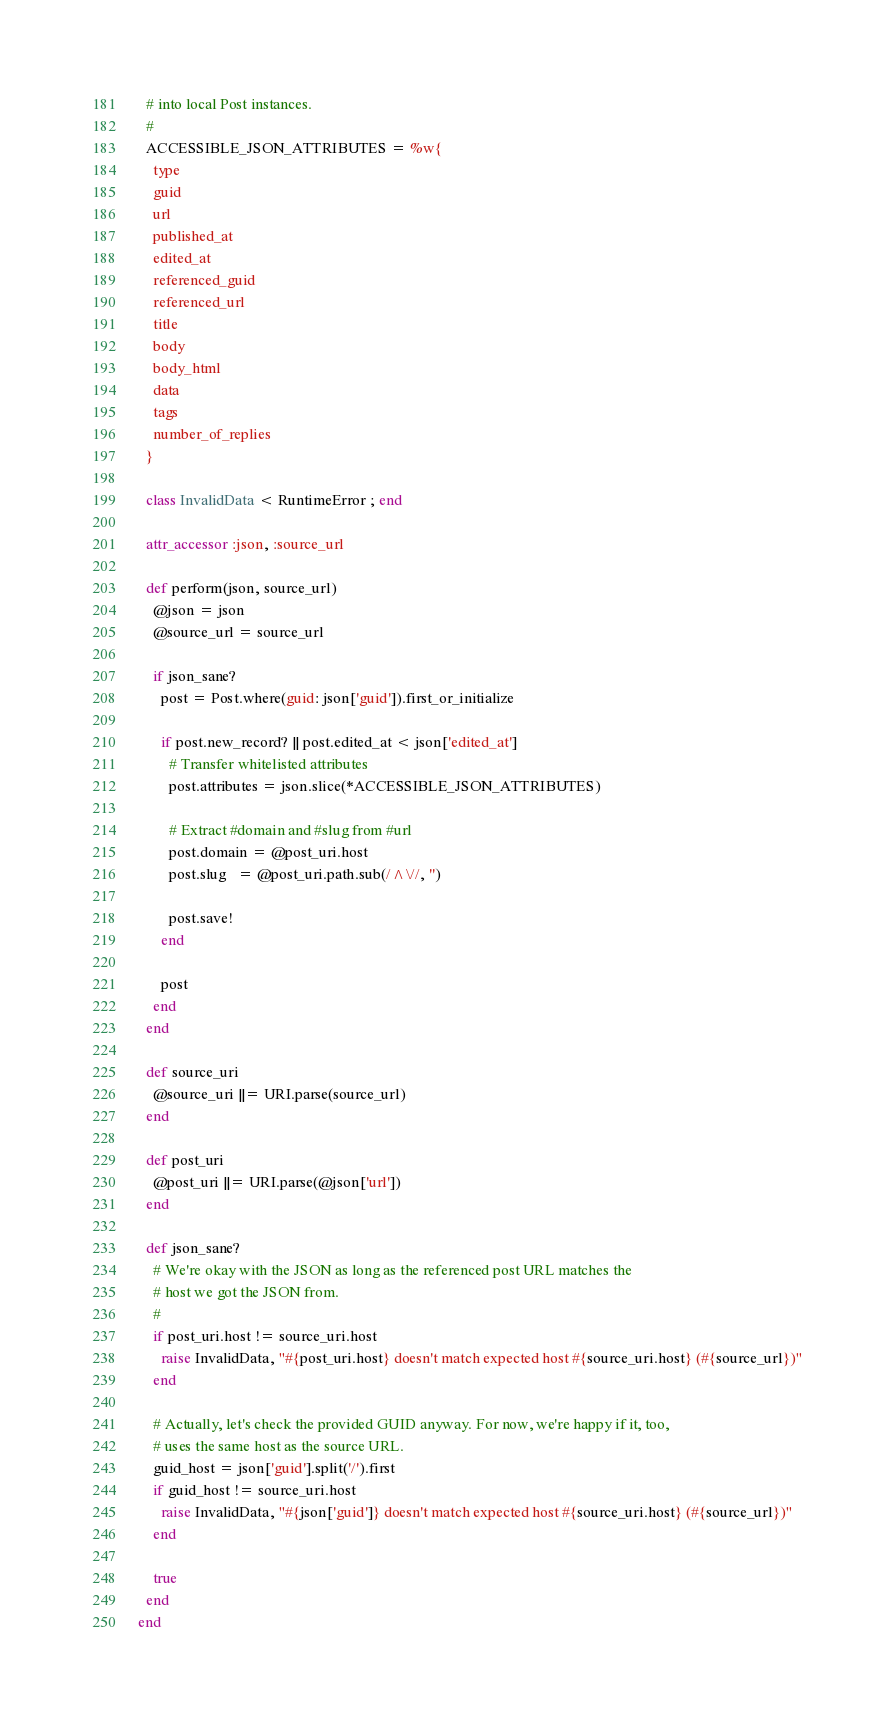Convert code to text. <code><loc_0><loc_0><loc_500><loc_500><_Ruby_>  # into local Post instances.
  #
  ACCESSIBLE_JSON_ATTRIBUTES = %w{
    type
    guid
    url
    published_at
    edited_at
    referenced_guid
    referenced_url
    title
    body
    body_html
    data
    tags
    number_of_replies
  }

  class InvalidData < RuntimeError ; end

  attr_accessor :json, :source_url

  def perform(json, source_url)
    @json = json
    @source_url = source_url

    if json_sane?
      post = Post.where(guid: json['guid']).first_or_initialize

      if post.new_record? || post.edited_at < json['edited_at']
        # Transfer whitelisted attributes
        post.attributes = json.slice(*ACCESSIBLE_JSON_ATTRIBUTES)

        # Extract #domain and #slug from #url
        post.domain = @post_uri.host
        post.slug   = @post_uri.path.sub(/^\//, '')

        post.save!
      end

      post
    end
  end

  def source_uri
    @source_uri ||= URI.parse(source_url)
  end

  def post_uri
    @post_uri ||= URI.parse(@json['url'])
  end

  def json_sane?
    # We're okay with the JSON as long as the referenced post URL matches the
    # host we got the JSON from.
    #
    if post_uri.host != source_uri.host
      raise InvalidData, "#{post_uri.host} doesn't match expected host #{source_uri.host} (#{source_url})"
    end

    # Actually, let's check the provided GUID anyway. For now, we're happy if it, too,
    # uses the same host as the source URL.
    guid_host = json['guid'].split('/').first
    if guid_host != source_uri.host
      raise InvalidData, "#{json['guid']} doesn't match expected host #{source_uri.host} (#{source_url})"
    end

    true
  end
end
</code> 